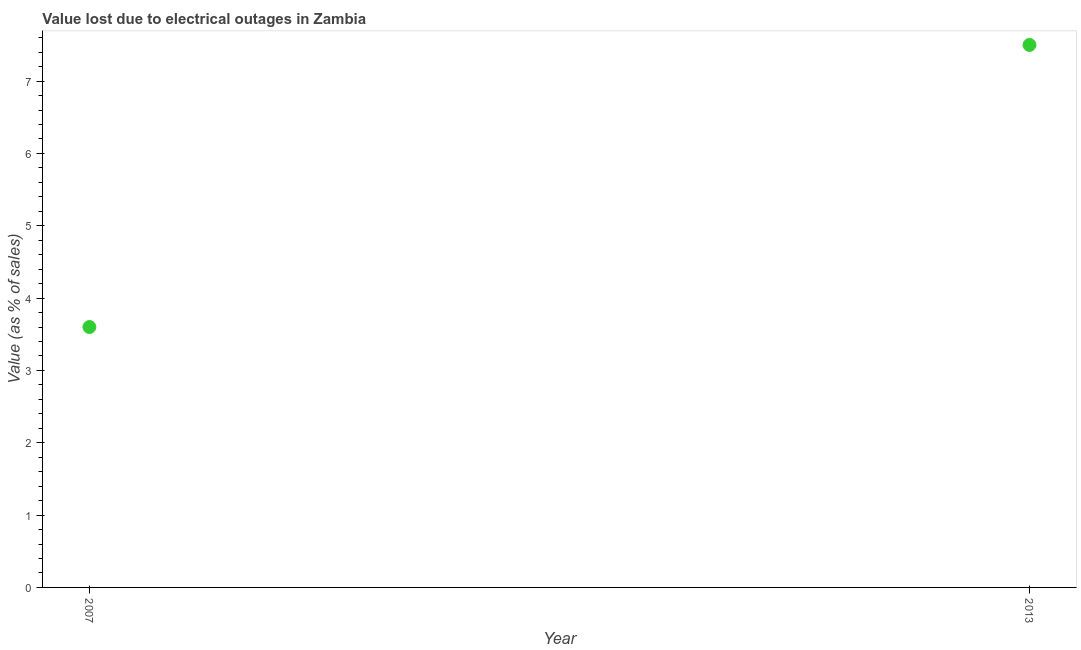In which year was the value lost due to electrical outages maximum?
Your answer should be compact. 2013. In which year was the value lost due to electrical outages minimum?
Offer a very short reply. 2007. What is the difference between the value lost due to electrical outages in 2007 and 2013?
Provide a short and direct response. -3.9. What is the average value lost due to electrical outages per year?
Offer a terse response. 5.55. What is the median value lost due to electrical outages?
Your answer should be very brief. 5.55. What is the ratio of the value lost due to electrical outages in 2007 to that in 2013?
Your answer should be compact. 0.48. In how many years, is the value lost due to electrical outages greater than the average value lost due to electrical outages taken over all years?
Your response must be concise. 1. What is the difference between two consecutive major ticks on the Y-axis?
Your answer should be compact. 1. Does the graph contain any zero values?
Make the answer very short. No. What is the title of the graph?
Offer a very short reply. Value lost due to electrical outages in Zambia. What is the label or title of the X-axis?
Provide a short and direct response. Year. What is the label or title of the Y-axis?
Offer a very short reply. Value (as % of sales). What is the ratio of the Value (as % of sales) in 2007 to that in 2013?
Give a very brief answer. 0.48. 